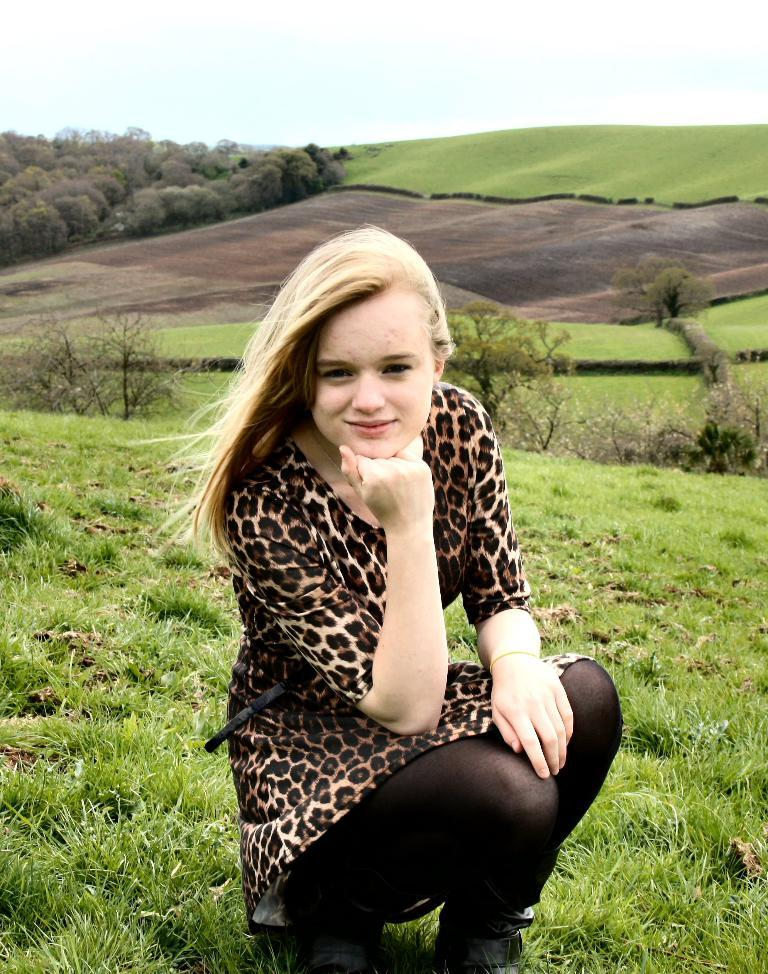Who is present in the image? There is a woman in the image. What position is the woman in? The woman is sitting in a squat position. What is the woman's facial expression? The woman is smiling. What type of environment is depicted in the image? There is grass and trees in the image, and it appears to depict a hill. What type of veil is the woman wearing in the image? There is no veil present in the image; the woman is not wearing any head covering. How many clovers can be seen in the image? There is no mention of clovers in the image; the focus is on the woman, her position, and the environment. 